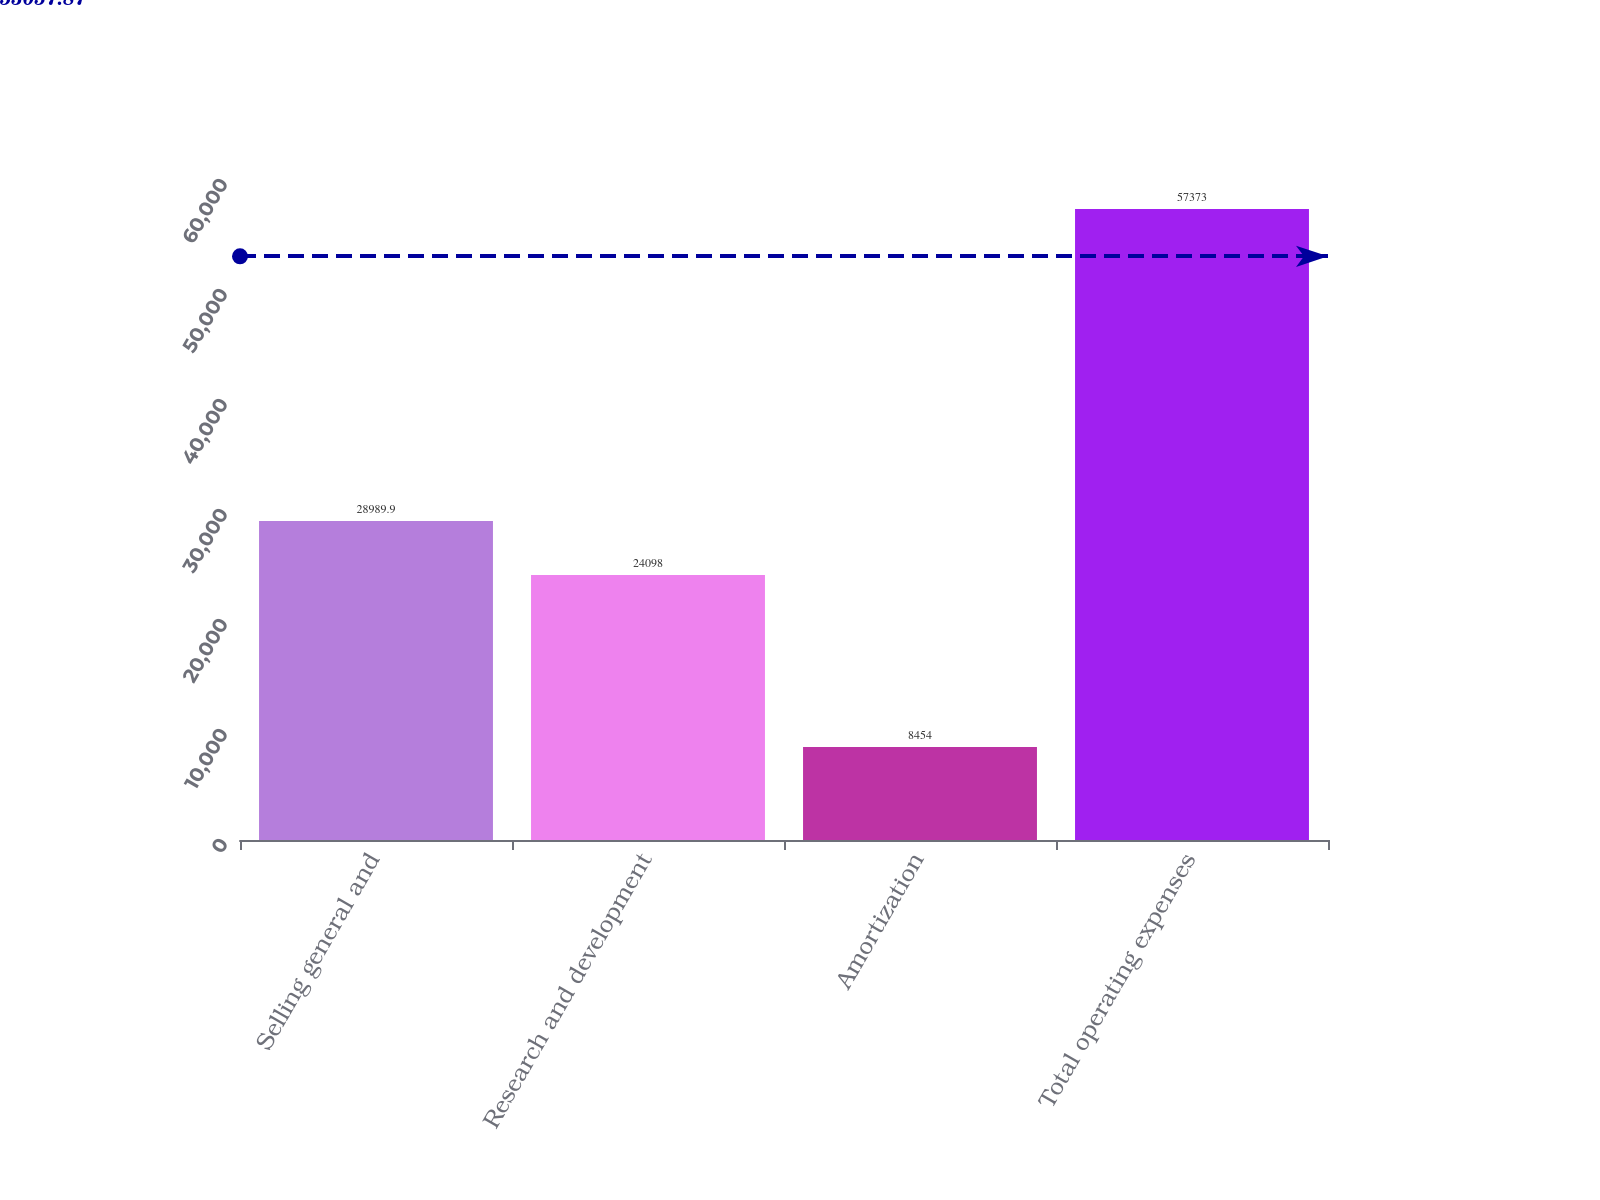<chart> <loc_0><loc_0><loc_500><loc_500><bar_chart><fcel>Selling general and<fcel>Research and development<fcel>Amortization<fcel>Total operating expenses<nl><fcel>28989.9<fcel>24098<fcel>8454<fcel>57373<nl></chart> 